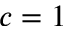Convert formula to latex. <formula><loc_0><loc_0><loc_500><loc_500>c = 1</formula> 